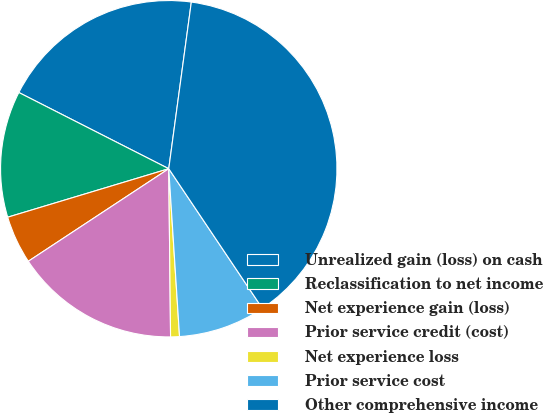Convert chart. <chart><loc_0><loc_0><loc_500><loc_500><pie_chart><fcel>Unrealized gain (loss) on cash<fcel>Reclassification to net income<fcel>Net experience gain (loss)<fcel>Prior service credit (cost)<fcel>Net experience loss<fcel>Prior service cost<fcel>Other comprehensive income<nl><fcel>19.66%<fcel>12.14%<fcel>4.62%<fcel>15.9%<fcel>0.85%<fcel>8.38%<fcel>38.46%<nl></chart> 